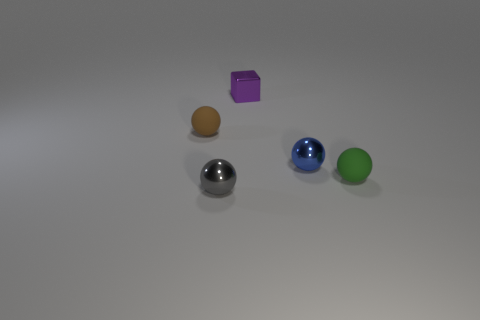Are there any other things that have the same shape as the purple thing?
Your answer should be compact. No. Are there more purple cubes behind the purple metallic object than metal balls that are behind the tiny brown matte ball?
Provide a short and direct response. No. What is the material of the tiny brown ball?
Offer a terse response. Rubber. What is the shape of the object left of the small thing in front of the rubber object right of the blue object?
Make the answer very short. Sphere. How many other things are there of the same material as the small brown object?
Offer a very short reply. 1. Does the small green ball in front of the blue sphere have the same material as the tiny sphere on the left side of the tiny gray object?
Your answer should be very brief. Yes. How many tiny objects are both to the left of the purple cube and to the right of the brown rubber sphere?
Give a very brief answer. 1. Is there another metal thing of the same shape as the gray metallic thing?
Provide a short and direct response. Yes. The purple metal object that is the same size as the brown rubber sphere is what shape?
Offer a terse response. Cube. Are there an equal number of purple cubes to the right of the small blue shiny ball and small gray balls right of the tiny gray metal sphere?
Ensure brevity in your answer.  Yes. 